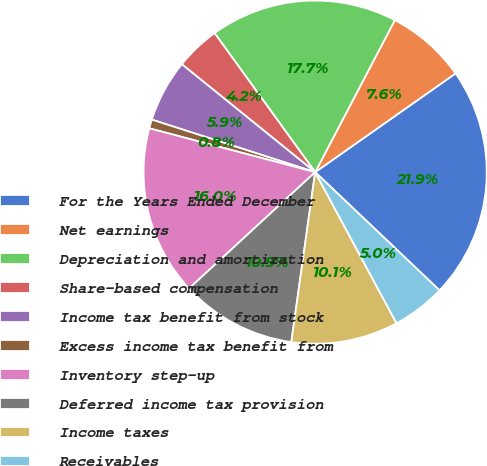Convert chart to OTSL. <chart><loc_0><loc_0><loc_500><loc_500><pie_chart><fcel>For the Years Ended December<fcel>Net earnings<fcel>Depreciation and amortization<fcel>Share-based compensation<fcel>Income tax benefit from stock<fcel>Excess income tax benefit from<fcel>Inventory step-up<fcel>Deferred income tax provision<fcel>Income taxes<fcel>Receivables<nl><fcel>21.85%<fcel>7.56%<fcel>17.65%<fcel>4.2%<fcel>5.88%<fcel>0.84%<fcel>15.97%<fcel>10.92%<fcel>10.08%<fcel>5.04%<nl></chart> 